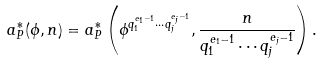Convert formula to latex. <formula><loc_0><loc_0><loc_500><loc_500>a _ { P } ^ { \ast } ( \phi , n ) = a _ { P } ^ { \ast } \left ( \phi ^ { q _ { 1 } ^ { e _ { 1 } - 1 } \cdots q _ { j } ^ { e _ { j } - 1 } } , \frac { n } { q _ { 1 } ^ { e _ { 1 } - 1 } \cdots q _ { j } ^ { e _ { j } - 1 } } \right ) .</formula> 